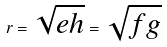<formula> <loc_0><loc_0><loc_500><loc_500>r = \sqrt { e h } = \sqrt { f g }</formula> 